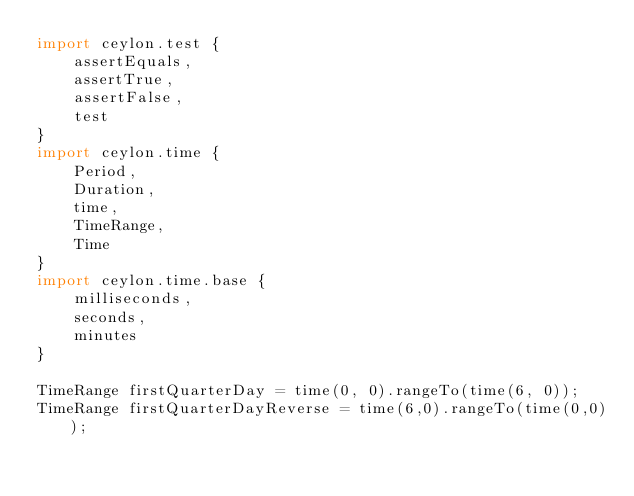Convert code to text. <code><loc_0><loc_0><loc_500><loc_500><_Ceylon_>import ceylon.test {
    assertEquals,
    assertTrue,
    assertFalse,
    test
}
import ceylon.time {
    Period,
    Duration,
    time,
    TimeRange,
    Time
}
import ceylon.time.base {
    milliseconds,
    seconds,
    minutes
}

TimeRange firstQuarterDay = time(0, 0).rangeTo(time(6, 0));
TimeRange firstQuarterDayReverse = time(6,0).rangeTo(time(0,0));</code> 